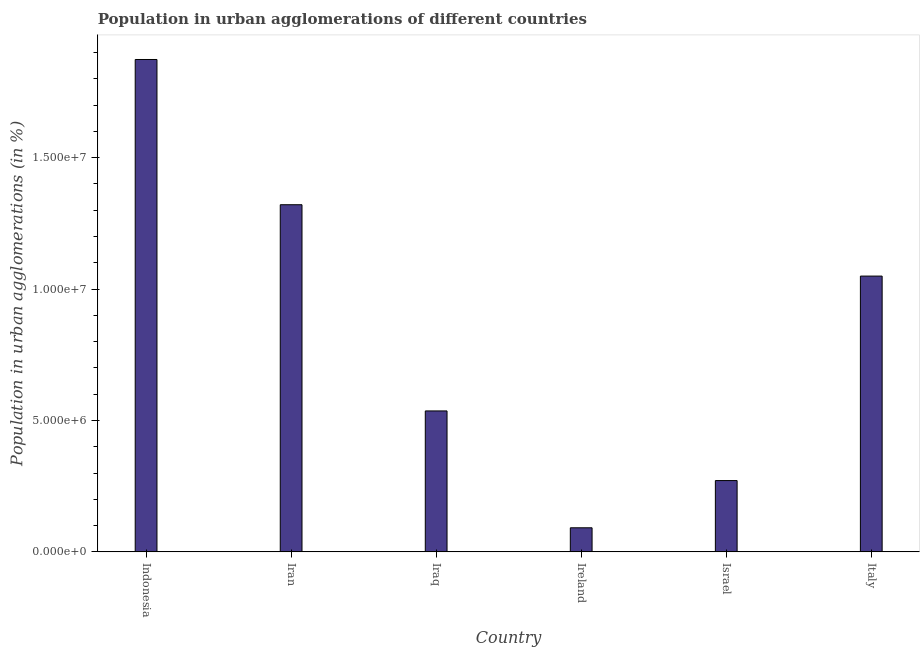Does the graph contain grids?
Your answer should be very brief. No. What is the title of the graph?
Offer a very short reply. Population in urban agglomerations of different countries. What is the label or title of the Y-axis?
Offer a very short reply. Population in urban agglomerations (in %). What is the population in urban agglomerations in Iran?
Your answer should be compact. 1.32e+07. Across all countries, what is the maximum population in urban agglomerations?
Your response must be concise. 1.87e+07. Across all countries, what is the minimum population in urban agglomerations?
Your response must be concise. 9.16e+05. In which country was the population in urban agglomerations maximum?
Your response must be concise. Indonesia. In which country was the population in urban agglomerations minimum?
Make the answer very short. Ireland. What is the sum of the population in urban agglomerations?
Provide a short and direct response. 5.14e+07. What is the difference between the population in urban agglomerations in Indonesia and Israel?
Make the answer very short. 1.60e+07. What is the average population in urban agglomerations per country?
Your answer should be very brief. 8.57e+06. What is the median population in urban agglomerations?
Offer a terse response. 7.93e+06. What is the ratio of the population in urban agglomerations in Israel to that in Italy?
Provide a succinct answer. 0.26. Is the population in urban agglomerations in Indonesia less than that in Iraq?
Offer a terse response. No. Is the difference between the population in urban agglomerations in Iraq and Italy greater than the difference between any two countries?
Provide a succinct answer. No. What is the difference between the highest and the second highest population in urban agglomerations?
Your answer should be compact. 5.53e+06. What is the difference between the highest and the lowest population in urban agglomerations?
Keep it short and to the point. 1.78e+07. In how many countries, is the population in urban agglomerations greater than the average population in urban agglomerations taken over all countries?
Provide a succinct answer. 3. Are the values on the major ticks of Y-axis written in scientific E-notation?
Your answer should be compact. Yes. What is the Population in urban agglomerations (in %) of Indonesia?
Keep it short and to the point. 1.87e+07. What is the Population in urban agglomerations (in %) of Iran?
Your response must be concise. 1.32e+07. What is the Population in urban agglomerations (in %) in Iraq?
Provide a succinct answer. 5.36e+06. What is the Population in urban agglomerations (in %) of Ireland?
Your response must be concise. 9.16e+05. What is the Population in urban agglomerations (in %) of Israel?
Make the answer very short. 2.71e+06. What is the Population in urban agglomerations (in %) in Italy?
Keep it short and to the point. 1.05e+07. What is the difference between the Population in urban agglomerations (in %) in Indonesia and Iran?
Keep it short and to the point. 5.53e+06. What is the difference between the Population in urban agglomerations (in %) in Indonesia and Iraq?
Make the answer very short. 1.34e+07. What is the difference between the Population in urban agglomerations (in %) in Indonesia and Ireland?
Keep it short and to the point. 1.78e+07. What is the difference between the Population in urban agglomerations (in %) in Indonesia and Israel?
Ensure brevity in your answer.  1.60e+07. What is the difference between the Population in urban agglomerations (in %) in Indonesia and Italy?
Provide a succinct answer. 8.24e+06. What is the difference between the Population in urban agglomerations (in %) in Iran and Iraq?
Keep it short and to the point. 7.85e+06. What is the difference between the Population in urban agglomerations (in %) in Iran and Ireland?
Give a very brief answer. 1.23e+07. What is the difference between the Population in urban agglomerations (in %) in Iran and Israel?
Ensure brevity in your answer.  1.05e+07. What is the difference between the Population in urban agglomerations (in %) in Iran and Italy?
Your answer should be compact. 2.72e+06. What is the difference between the Population in urban agglomerations (in %) in Iraq and Ireland?
Provide a short and direct response. 4.45e+06. What is the difference between the Population in urban agglomerations (in %) in Iraq and Israel?
Your answer should be compact. 2.65e+06. What is the difference between the Population in urban agglomerations (in %) in Iraq and Italy?
Your response must be concise. -5.13e+06. What is the difference between the Population in urban agglomerations (in %) in Ireland and Israel?
Your answer should be very brief. -1.80e+06. What is the difference between the Population in urban agglomerations (in %) in Ireland and Italy?
Provide a short and direct response. -9.58e+06. What is the difference between the Population in urban agglomerations (in %) in Israel and Italy?
Your response must be concise. -7.78e+06. What is the ratio of the Population in urban agglomerations (in %) in Indonesia to that in Iran?
Provide a short and direct response. 1.42. What is the ratio of the Population in urban agglomerations (in %) in Indonesia to that in Iraq?
Keep it short and to the point. 3.49. What is the ratio of the Population in urban agglomerations (in %) in Indonesia to that in Ireland?
Provide a succinct answer. 20.45. What is the ratio of the Population in urban agglomerations (in %) in Indonesia to that in Israel?
Your answer should be very brief. 6.91. What is the ratio of the Population in urban agglomerations (in %) in Indonesia to that in Italy?
Ensure brevity in your answer.  1.78. What is the ratio of the Population in urban agglomerations (in %) in Iran to that in Iraq?
Your answer should be compact. 2.46. What is the ratio of the Population in urban agglomerations (in %) in Iran to that in Ireland?
Provide a short and direct response. 14.42. What is the ratio of the Population in urban agglomerations (in %) in Iran to that in Israel?
Provide a short and direct response. 4.87. What is the ratio of the Population in urban agglomerations (in %) in Iran to that in Italy?
Ensure brevity in your answer.  1.26. What is the ratio of the Population in urban agglomerations (in %) in Iraq to that in Ireland?
Give a very brief answer. 5.85. What is the ratio of the Population in urban agglomerations (in %) in Iraq to that in Israel?
Offer a terse response. 1.98. What is the ratio of the Population in urban agglomerations (in %) in Iraq to that in Italy?
Make the answer very short. 0.51. What is the ratio of the Population in urban agglomerations (in %) in Ireland to that in Israel?
Keep it short and to the point. 0.34. What is the ratio of the Population in urban agglomerations (in %) in Ireland to that in Italy?
Offer a very short reply. 0.09. What is the ratio of the Population in urban agglomerations (in %) in Israel to that in Italy?
Keep it short and to the point. 0.26. 